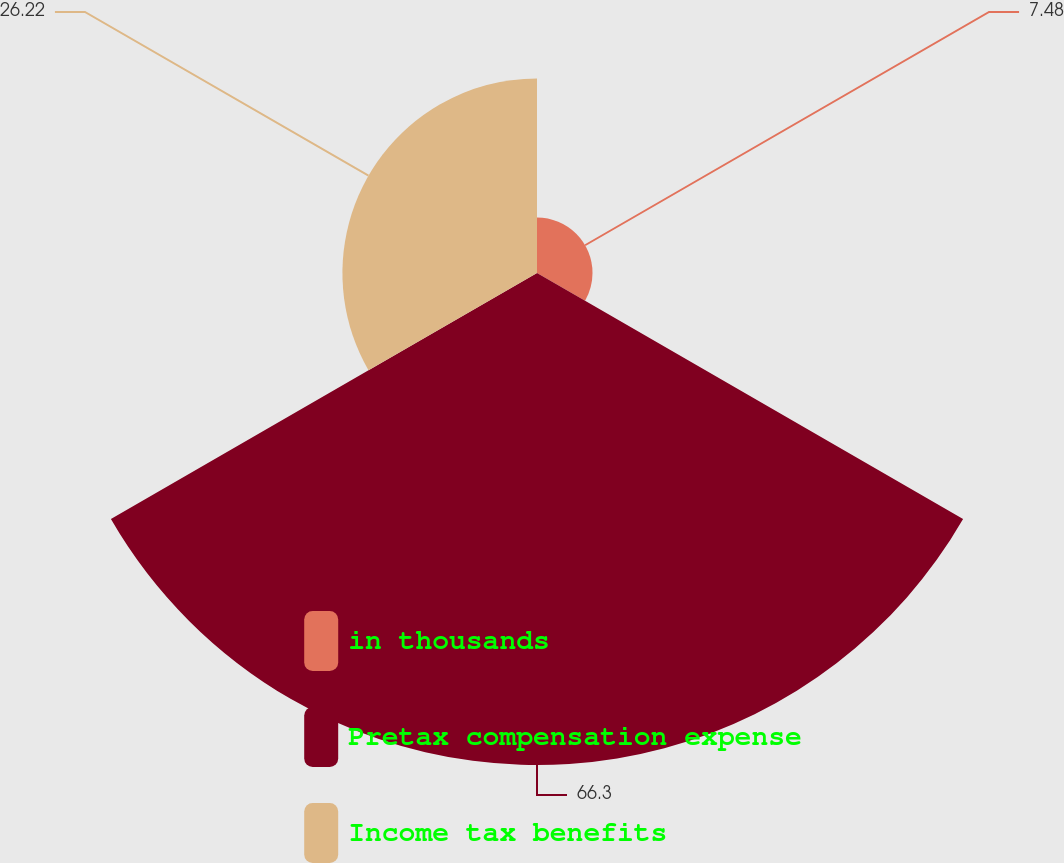Convert chart to OTSL. <chart><loc_0><loc_0><loc_500><loc_500><pie_chart><fcel>in thousands<fcel>Pretax compensation expense<fcel>Income tax benefits<nl><fcel>7.48%<fcel>66.3%<fcel>26.22%<nl></chart> 